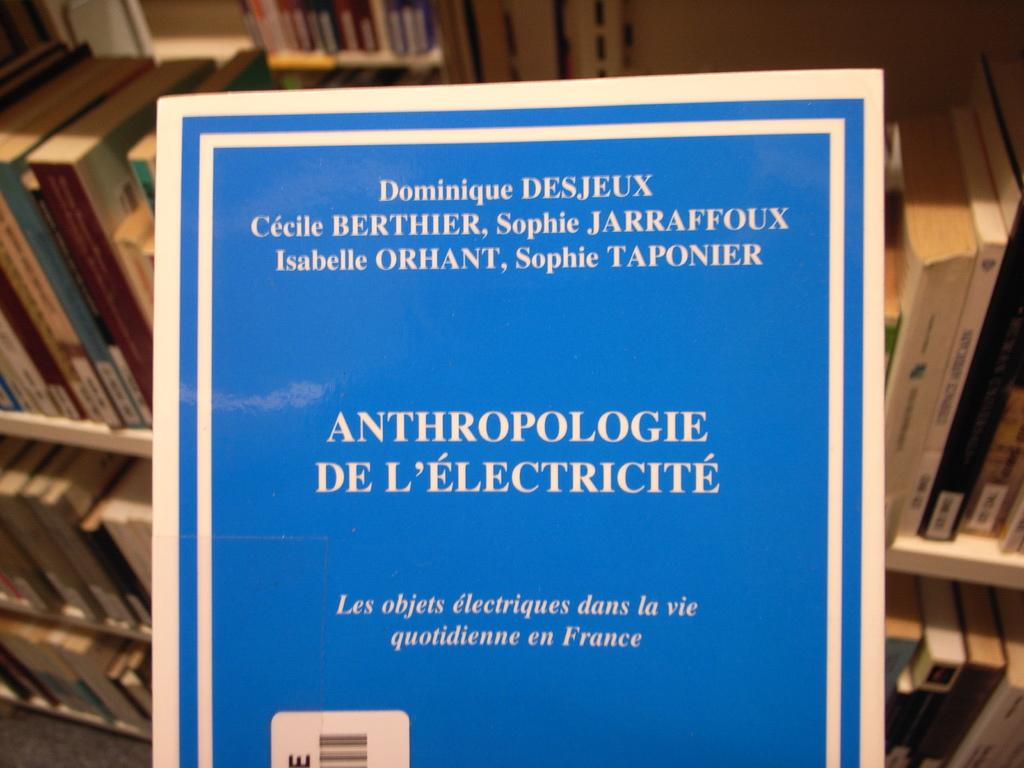<image>
Write a terse but informative summary of the picture. A document regarding anthropologie de l'electricite by Dominique Desjeeux 